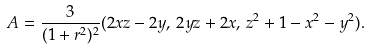Convert formula to latex. <formula><loc_0><loc_0><loc_500><loc_500>A = \frac { 3 } { ( 1 + r ^ { 2 } ) ^ { 2 } } ( 2 x z - 2 y , \, 2 y z + 2 x , \, z ^ { 2 } + 1 - x ^ { 2 } - y ^ { 2 } ) .</formula> 